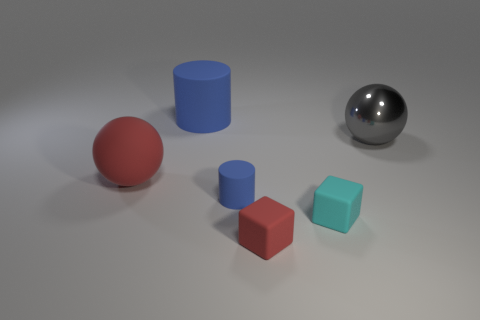Add 2 large gray things. How many objects exist? 8 Subtract all cubes. How many objects are left? 4 Add 2 rubber spheres. How many rubber spheres exist? 3 Subtract 0 red cylinders. How many objects are left? 6 Subtract all large green metal cylinders. Subtract all blue rubber objects. How many objects are left? 4 Add 6 large shiny things. How many large shiny things are left? 7 